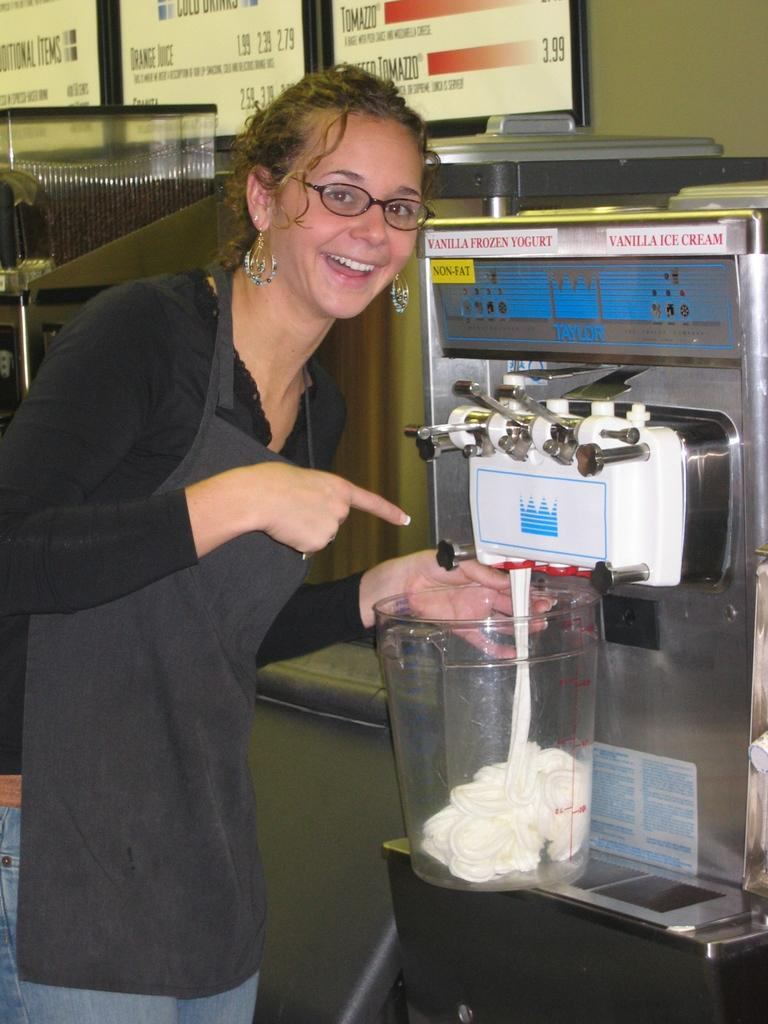<image>
Summarize the visual content of the image. a woman pointing to a vat filling up at a Vanilla Frozen Yogurt and Ice Cream machine 